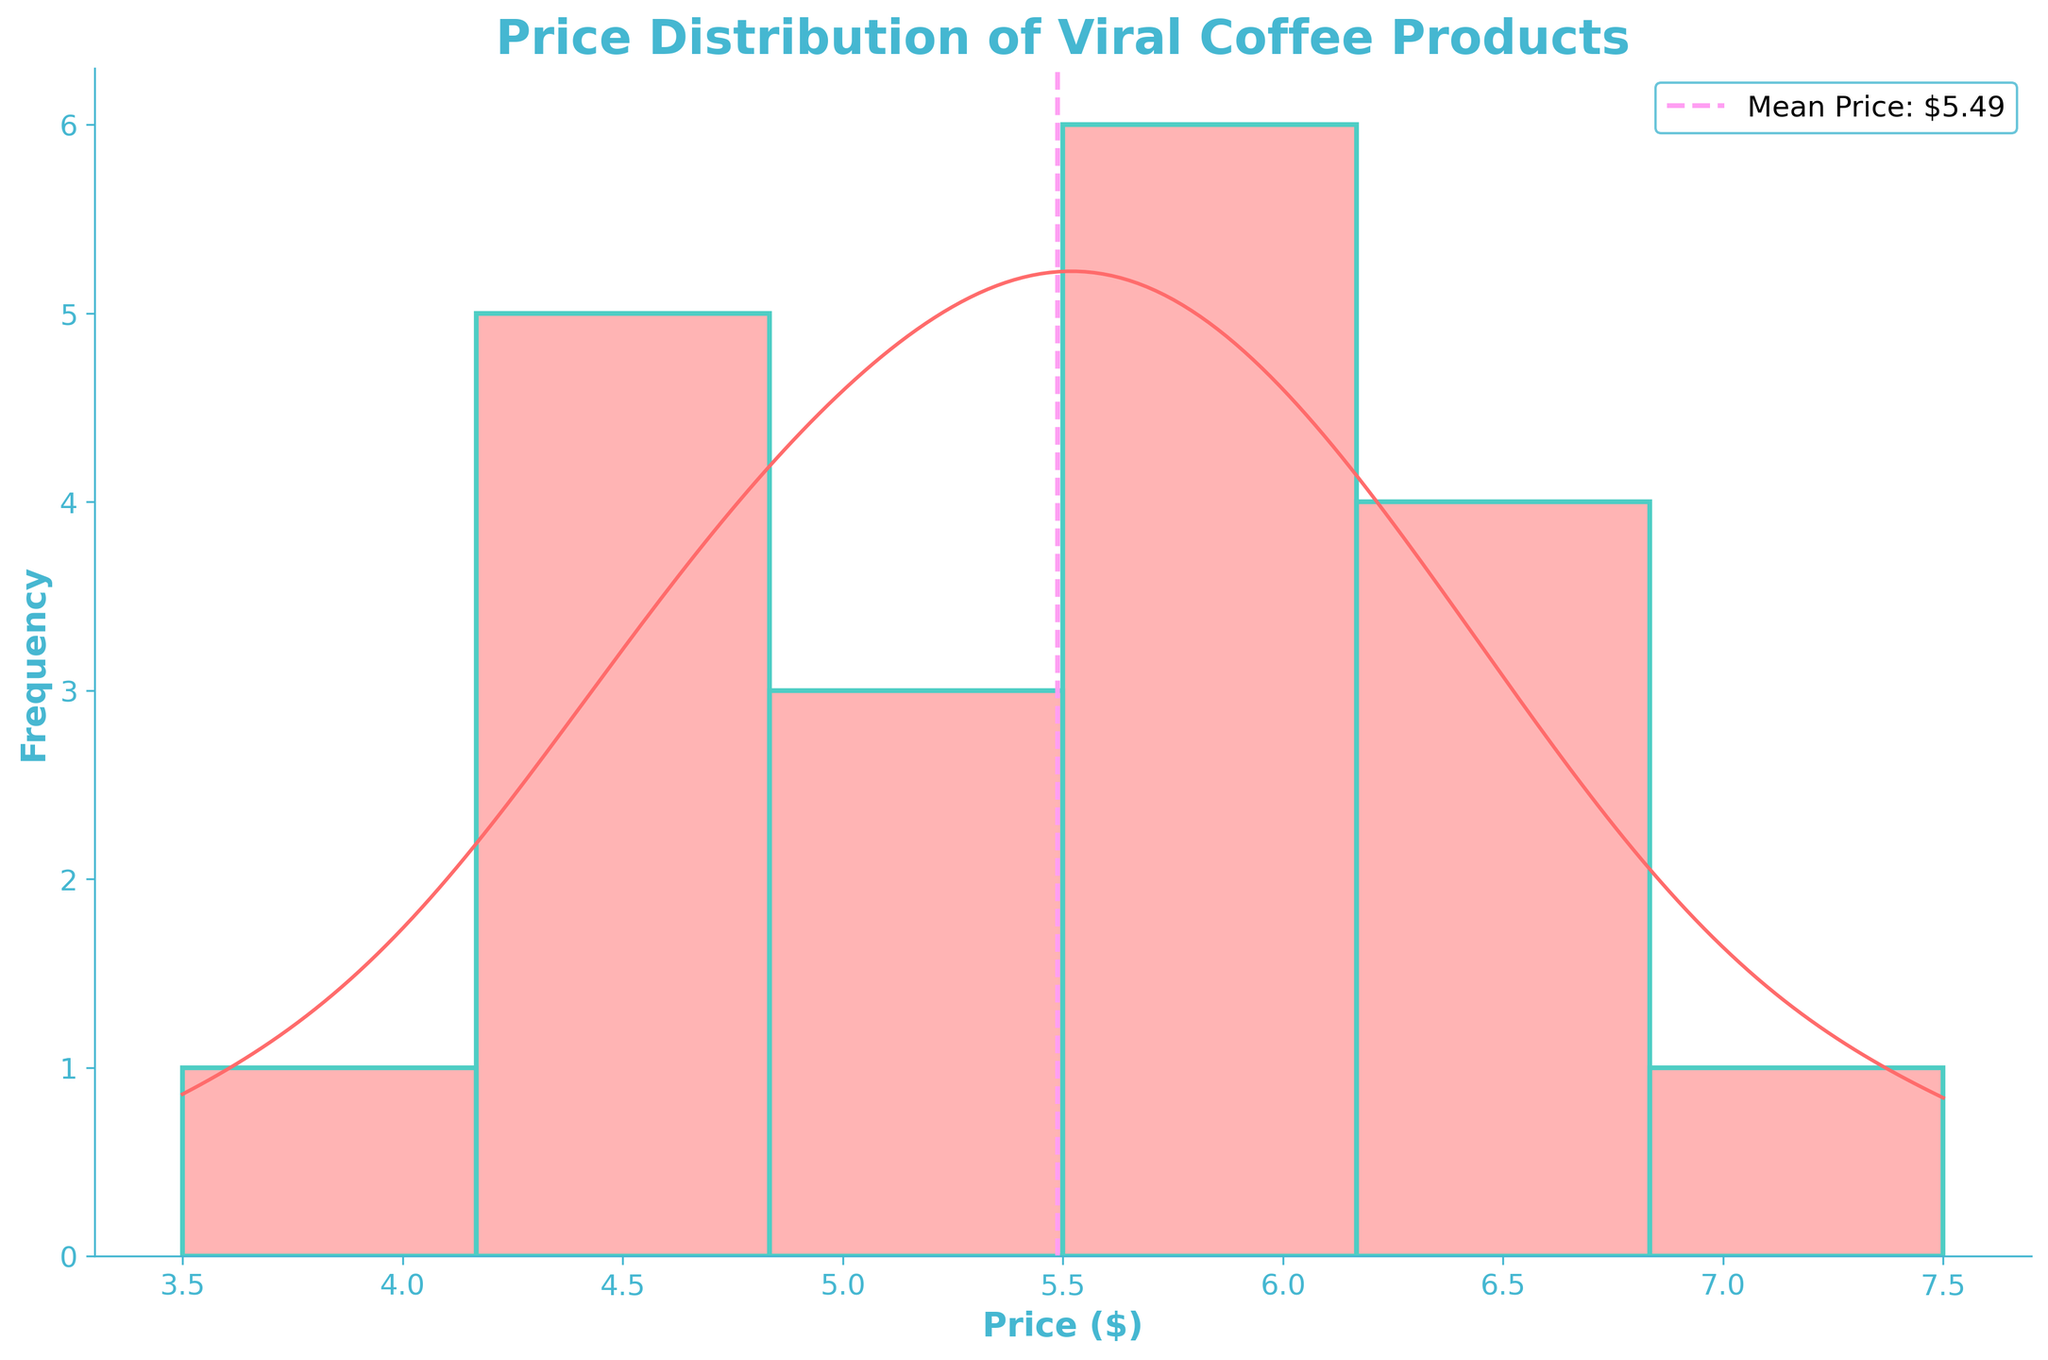What's the title of the figure? The title of the figure is shown at the top and usually summarizes the main topic of the plot.
Answer: Price Distribution of Viral Coffee Products What color is the density curve in the plot? The color of the density curve can be identified by looking closely at the curve itself.
Answer: Red What is the mean price of the viral coffee products according to the plot? The mean price is represented by a vertical dashed line on the plot, and it is specified in the legend as well.
Answer: $5.54 How many viral coffee products are within the $4.00-$5.00 price range? For spotting this, visually estimate the number of bars (or portion of bars) within the specified price range on the histogram.
Answer: 4 Which price range has the highest frequency of coffee products? The range with the highest frequency can be observed by looking at the tallest bar in the histogram.
Answer: $5.00-$6.00 What price does the density curve peak at? The peak of the density curve can be seen where the curve reaches its highest point.
Answer: Around $5.75 How does the number of products priced at around $7.50 compare to those priced at around $4.75? Compare the heights of the histogram bars at the specified prices to determine which has more coffee products.
Answer: Fewer at $7.50 than $4.75 Are there more products priced above or below the mean price? Determine the distribution of the bars relative to the mean price line to estimate the number of products above and below it.
Answer: Below What does the density curve suggest about the distribution of coffee prices? The shape and spread of the density curve provide insights into the overall distribution, such as skewness and modality.
Answer: Positively skewed with a peak near $5.75 Is the distribution of coffee prices skewed? If so, in which direction? Identify the skewness by observing the density curve: if the tail is longer on one side, it indicates skewness.
Answer: Right (positively) skewed 